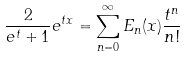Convert formula to latex. <formula><loc_0><loc_0><loc_500><loc_500>\frac { 2 } { e ^ { t } + 1 } e ^ { t x } = \sum _ { n = 0 } ^ { \infty } E _ { n } ( x ) \frac { t ^ { n } } { n ! }</formula> 